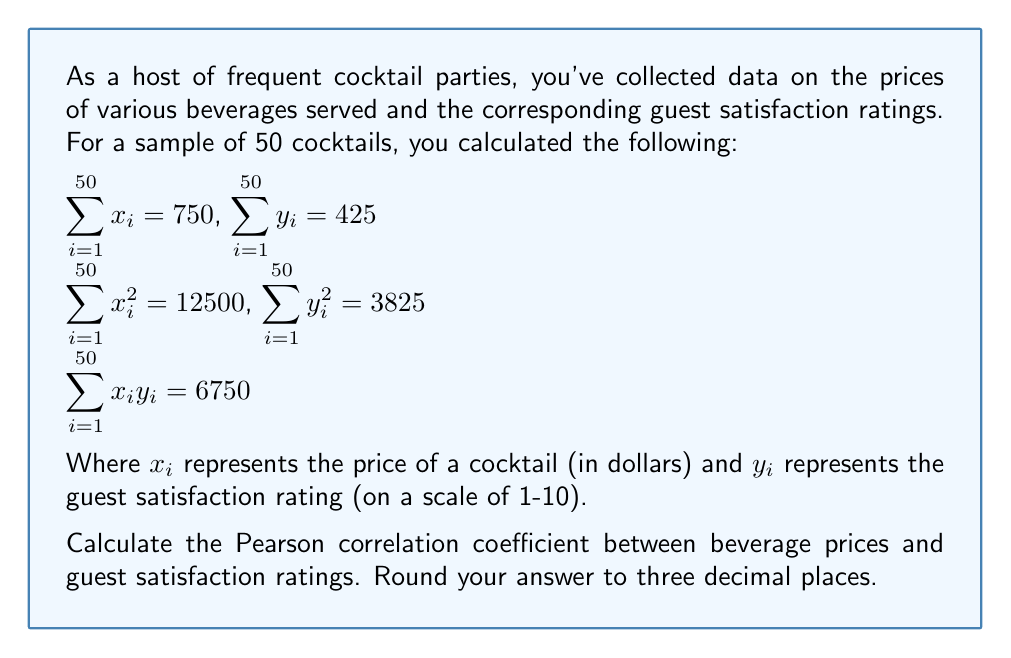Solve this math problem. To calculate the Pearson correlation coefficient, we'll use the formula:

$$r = \frac{n\sum x_iy_i - (\sum x_i)(\sum y_i)}{\sqrt{[n\sum x_i^2 - (\sum x_i)^2][n\sum y_i^2 - (\sum y_i)^2]}}$$

Where:
$n$ = number of samples = 50
$\sum x_iy_i = 6750$
$\sum x_i = 750$
$\sum y_i = 425$
$\sum x_i^2 = 12500$
$\sum y_i^2 = 3825$

Let's calculate step by step:

1) First, calculate the numerator:
   $50 * 6750 - (750 * 425) = 337500 - 318750 = 18750$

2) Now, calculate the two parts of the denominator:
   $50 * 12500 - 750^2 = 625000 - 562500 = 62500$
   $50 * 3825 - 425^2 = 191250 - 180625 = 10625$

3) Multiply these parts:
   $62500 * 10625 = 664062500$

4) Take the square root:
   $\sqrt{664062500} = 25768.33$ (rounded to 2 decimal places)

5) Now, divide the numerator by this value:
   $18750 / 25768.33 = 0.72764$ (rounded to 5 decimal places)

Therefore, the Pearson correlation coefficient is approximately 0.728 when rounded to three decimal places.
Answer: 0.728 